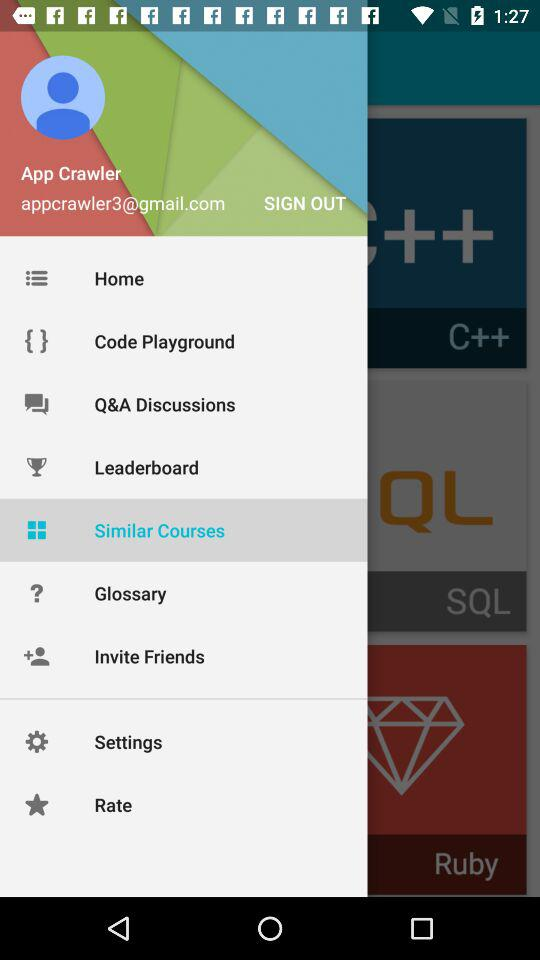How many programming languages are there?
Answer the question using a single word or phrase. 3 